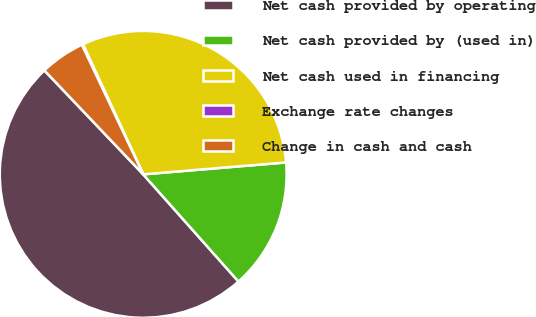Convert chart. <chart><loc_0><loc_0><loc_500><loc_500><pie_chart><fcel>Net cash provided by operating<fcel>Net cash provided by (used in)<fcel>Net cash used in financing<fcel>Exchange rate changes<fcel>Change in cash and cash<nl><fcel>49.46%<fcel>14.76%<fcel>30.58%<fcel>0.13%<fcel>5.06%<nl></chart> 